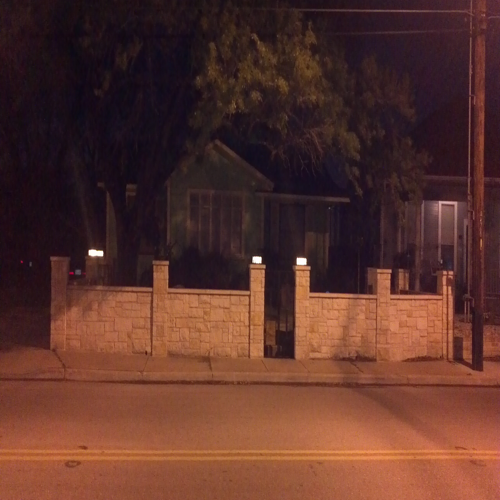Can you describe the type of neighborhood that this image might represent? The image appears to depict a residential neighborhood, characterized by private homes set back from the street with a barrier, which indicates a preference for privacy and possibly a suburban setting. 